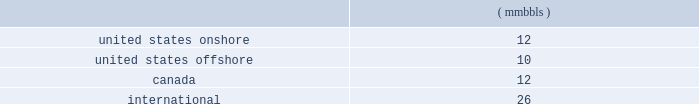46 d e v o n e n e r g y a n n u a l r e p o r t 2 0 0 4 contents of gas produced , transportation availability and costs and demand for the various products derived from oil , natural gas and ngls .
Substantially all of devon 2019s revenues are attributable to sales , processing and transportation of these three commodities .
Consequently , our financial results and resources are highly influenced by price volatility .
Estimates for devon 2019s future production of oil , natural gas and ngls are based on the assumption that market demand and prices will continue at levels that allow for profitable production of these products .
There can be no assurance of such stability .
Most of our canadian production is subject to government royalties that fluctuate with prices .
Thus , price fluctuations can affect reported production .
Also , our international production is governed by payout agreements with the governments of the countries in which we operate .
If the payout under these agreements is attained earlier than projected , devon 2019s net production and proved reserves in such areas could be reduced .
Estimates for our future processing and transport of oil , natural gas and ngls are based on the assumption that market demand and prices will continue at levels that allow for profitable processing and transport of these products .
There can be no assurance of such stability .
The production , transportation , processing and marketing of oil , natural gas and ngls are complex processes which are subject to disruption from many causes .
These causes include transportation and processing availability , mechanical failure , human error , meteorological events including , but not limited to , hurricanes , and numerous other factors .
The following forward-looking statements were prepared assuming demand , curtailment , producibility and general market conditions for devon 2019s oil , natural gas and ngls during 2005 will be substantially similar to those of 2004 , unless otherwise noted .
Unless otherwise noted , all of the following dollar amounts are expressed in u.s .
Dollars .
Amounts related to canadian operations have been converted to u.s .
Dollars using a projected average 2005 exchange rate of $ 0.82 u.s .
To $ 1.00 canadian .
The actual 2005 exchange rate may vary materially from this estimate .
Such variations could have a material effect on the following estimates .
Though we have completed several major property acquisitions and dispositions in recent years , these transactions are opportunity driven .
Thus , the following forward-looking data excludes the financial and operating effects of potential property acquisitions or divestitures , except as discussed in 201cproperty acquisitions and divestitures , 201d during the year 2005 .
The timing and ultimate results of such acquisition and divestiture activity is difficult to predict , and may vary materially from that discussed in this report .
Geographic reporting areas for 2005 the following estimates of production , average price differentials and capital expenditures are provided separately for each of the following geographic areas : 2022 the united states onshore ; 2022 the united states offshore , which encompasses all oil and gas properties in the gulf of mexico ; 2022 canada ; and 2022 international , which encompasses all oil and gas properties that lie outside of the united states and canada .
Year 2005 potential operating items the estimates related to oil , gas and ngl production , operating costs and dd&a set forth in the following paragraphs are based on estimates for devon 2019s properties other than those that have been designated for possible sale ( see 201cproperty acquisitions and divestitures 201d ) .
Therefore , the following estimates exclude the results of the potential sale properties for the entire year .
Oil , gas and ngl production set forth in the following paragraphs are individual estimates of devon 2019s oil , gas and ngl production for 2005 .
On a combined basis , devon estimates its 2005 oil , gas and ngl production will total 217 mmboe .
Of this total , approximately 92% ( 92 % ) is estimated to be produced from reserves classified as 201cproved 201d at december 31 , 2004 .
Oil production we expect our oil production in 2005 to total 60 mmbbls .
Of this total , approximately 95% ( 95 % ) is estimated to be produced from reserves classified as 201cproved 201d at december 31 , 2004 .
The expected production by area is as follows: .
Oil prices 2013 fixed through various price swaps , devon has fixed the price it will receive in 2005 on a portion of its oil production .
The following table includes information on this fixed-price production by area .
Where necessary , the prices have been adjusted for certain transportation costs that are netted against the prices recorded by devon. .
How much of the oil production is estimated to be produced from unproved reserves at dec 31 , 2004 , in mmbbls? 
Computations: (60 * ((100 / 95) / 100))
Answer: 0.63158. 